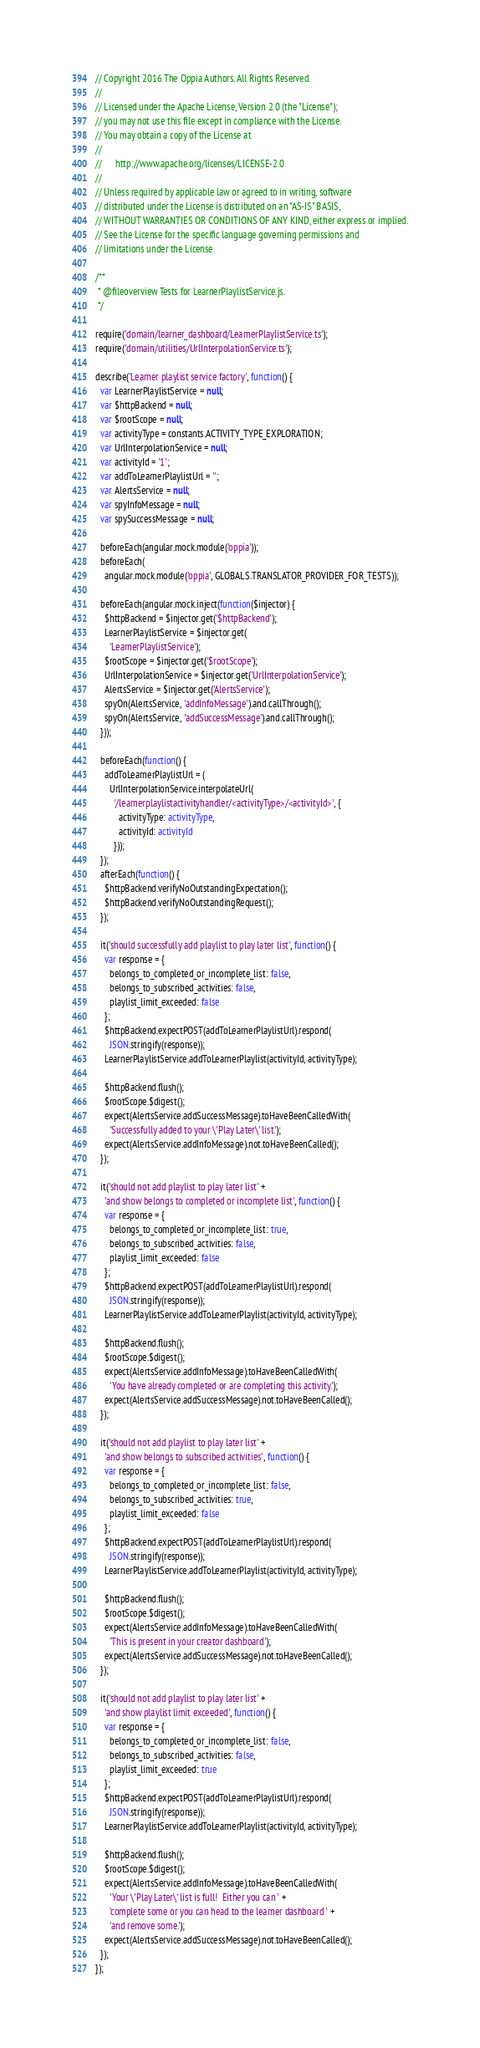<code> <loc_0><loc_0><loc_500><loc_500><_TypeScript_>// Copyright 2016 The Oppia Authors. All Rights Reserved.
//
// Licensed under the Apache License, Version 2.0 (the "License");
// you may not use this file except in compliance with the License.
// You may obtain a copy of the License at
//
//      http://www.apache.org/licenses/LICENSE-2.0
//
// Unless required by applicable law or agreed to in writing, software
// distributed under the License is distributed on an "AS-IS" BASIS,
// WITHOUT WARRANTIES OR CONDITIONS OF ANY KIND, either express or implied.
// See the License for the specific language governing permissions and
// limitations under the License.

/**
 * @fileoverview Tests for LearnerPlaylistService.js.
 */

require('domain/learner_dashboard/LearnerPlaylistService.ts');
require('domain/utilities/UrlInterpolationService.ts');

describe('Learner playlist service factory', function() {
  var LearnerPlaylistService = null;
  var $httpBackend = null;
  var $rootScope = null;
  var activityType = constants.ACTIVITY_TYPE_EXPLORATION;
  var UrlInterpolationService = null;
  var activityId = '1';
  var addToLearnerPlaylistUrl = '';
  var AlertsService = null;
  var spyInfoMessage = null;
  var spySuccessMessage = null;

  beforeEach(angular.mock.module('oppia'));
  beforeEach(
    angular.mock.module('oppia', GLOBALS.TRANSLATOR_PROVIDER_FOR_TESTS));

  beforeEach(angular.mock.inject(function($injector) {
    $httpBackend = $injector.get('$httpBackend');
    LearnerPlaylistService = $injector.get(
      'LearnerPlaylistService');
    $rootScope = $injector.get('$rootScope');
    UrlInterpolationService = $injector.get('UrlInterpolationService');
    AlertsService = $injector.get('AlertsService');
    spyOn(AlertsService, 'addInfoMessage').and.callThrough();
    spyOn(AlertsService, 'addSuccessMessage').and.callThrough();
  }));

  beforeEach(function() {
    addToLearnerPlaylistUrl = (
      UrlInterpolationService.interpolateUrl(
        '/learnerplaylistactivityhandler/<activityType>/<activityId>', {
          activityType: activityType,
          activityId: activityId
        }));
  });
  afterEach(function() {
    $httpBackend.verifyNoOutstandingExpectation();
    $httpBackend.verifyNoOutstandingRequest();
  });

  it('should successfully add playlist to play later list', function() {
    var response = {
      belongs_to_completed_or_incomplete_list: false,
      belongs_to_subscribed_activities: false,
      playlist_limit_exceeded: false
    };
    $httpBackend.expectPOST(addToLearnerPlaylistUrl).respond(
      JSON.stringify(response));
    LearnerPlaylistService.addToLearnerPlaylist(activityId, activityType);

    $httpBackend.flush();
    $rootScope.$digest();
    expect(AlertsService.addSuccessMessage).toHaveBeenCalledWith(
      'Successfully added to your \'Play Later\' list.');
    expect(AlertsService.addInfoMessage).not.toHaveBeenCalled();
  });

  it('should not add playlist to play later list' +
    'and show belongs to completed or incomplete list', function() {
    var response = {
      belongs_to_completed_or_incomplete_list: true,
      belongs_to_subscribed_activities: false,
      playlist_limit_exceeded: false
    };
    $httpBackend.expectPOST(addToLearnerPlaylistUrl).respond(
      JSON.stringify(response));
    LearnerPlaylistService.addToLearnerPlaylist(activityId, activityType);

    $httpBackend.flush();
    $rootScope.$digest();
    expect(AlertsService.addInfoMessage).toHaveBeenCalledWith(
      'You have already completed or are completing this activity.');
    expect(AlertsService.addSuccessMessage).not.toHaveBeenCalled();
  });

  it('should not add playlist to play later list' +
    'and show belongs to subscribed activities', function() {
    var response = {
      belongs_to_completed_or_incomplete_list: false,
      belongs_to_subscribed_activities: true,
      playlist_limit_exceeded: false
    };
    $httpBackend.expectPOST(addToLearnerPlaylistUrl).respond(
      JSON.stringify(response));
    LearnerPlaylistService.addToLearnerPlaylist(activityId, activityType);

    $httpBackend.flush();
    $rootScope.$digest();
    expect(AlertsService.addInfoMessage).toHaveBeenCalledWith(
      'This is present in your creator dashboard');
    expect(AlertsService.addSuccessMessage).not.toHaveBeenCalled();
  });

  it('should not add playlist to play later list' +
    'and show playlist limit exceeded', function() {
    var response = {
      belongs_to_completed_or_incomplete_list: false,
      belongs_to_subscribed_activities: false,
      playlist_limit_exceeded: true
    };
    $httpBackend.expectPOST(addToLearnerPlaylistUrl).respond(
      JSON.stringify(response));
    LearnerPlaylistService.addToLearnerPlaylist(activityId, activityType);

    $httpBackend.flush();
    $rootScope.$digest();
    expect(AlertsService.addInfoMessage).toHaveBeenCalledWith(
      'Your \'Play Later\' list is full!  Either you can ' +
      'complete some or you can head to the learner dashboard ' +
      'and remove some.');
    expect(AlertsService.addSuccessMessage).not.toHaveBeenCalled();
  });
});
</code> 